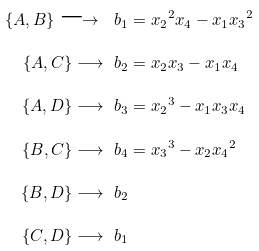Convert formula to latex. <formula><loc_0><loc_0><loc_500><loc_500>\{ A , B \} \longrightarrow \ b _ { 1 } & = { x _ { 2 } } ^ { 2 } { x _ { 4 } } - { x _ { 1 } } { x _ { 3 } } ^ { 2 } \\ \{ A , C \} \longrightarrow \ b _ { 2 } & = { x _ { 2 } } { x _ { 3 } } - { x _ { 1 } } { x _ { 4 } } \\ \{ A , D \} \longrightarrow \ b _ { 3 } & = { x _ { 2 } } ^ { 3 } - { x _ { 1 } } { x _ { 3 } } { x _ { 4 } } \\ \{ B , C \} \longrightarrow \ b _ { 4 } & = { x _ { 3 } } ^ { 3 } - { x _ { 2 } } { x _ { 4 } } ^ { 2 } \\ \{ B , D \} \longrightarrow \ b _ { 2 } & \\ \{ C , D \} \longrightarrow \ b _ { 1 } &</formula> 